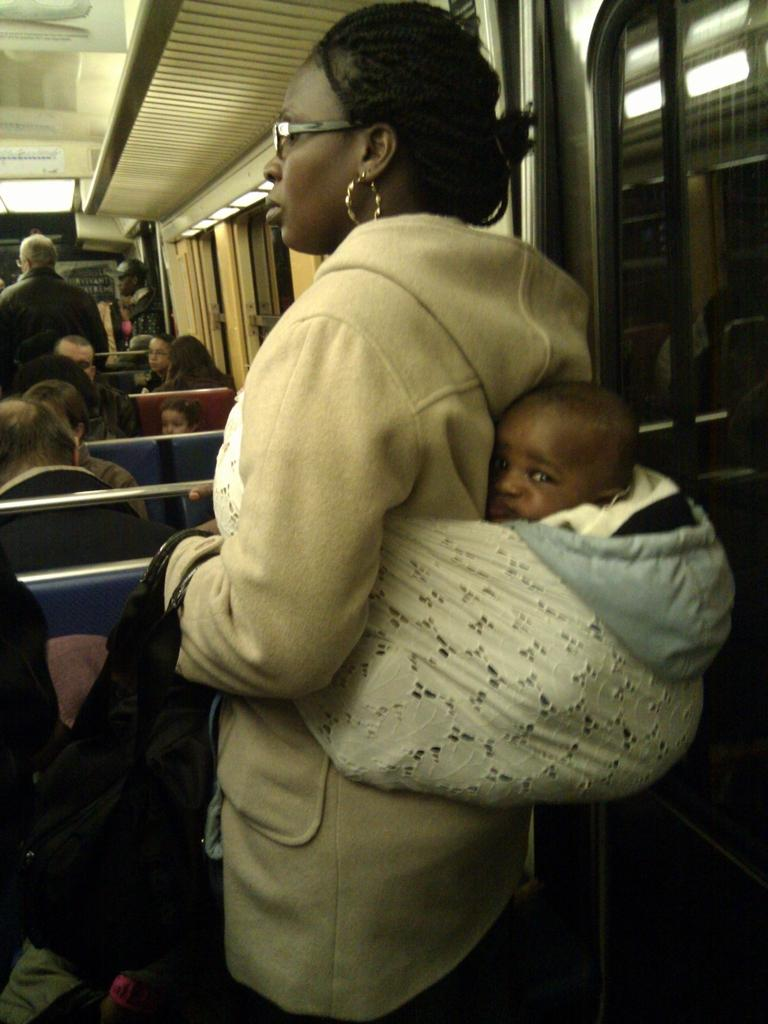What is the woman in the image doing? The woman is carrying a baby in the image. Where are the people sitting in the image? There are people sitting on chairs on the left side of the image. What type of architectural feature is present on the right side of the image? There are glass windows on the right side of the image. What can be seen at the top of the image? There are objects visible at the top of the image. What type of cheese is being used to decorate the bushes in the image? There are no bushes or cheese present in the image. Can you describe the mountain range visible in the background of the image? There is no mountain range visible in the image. 